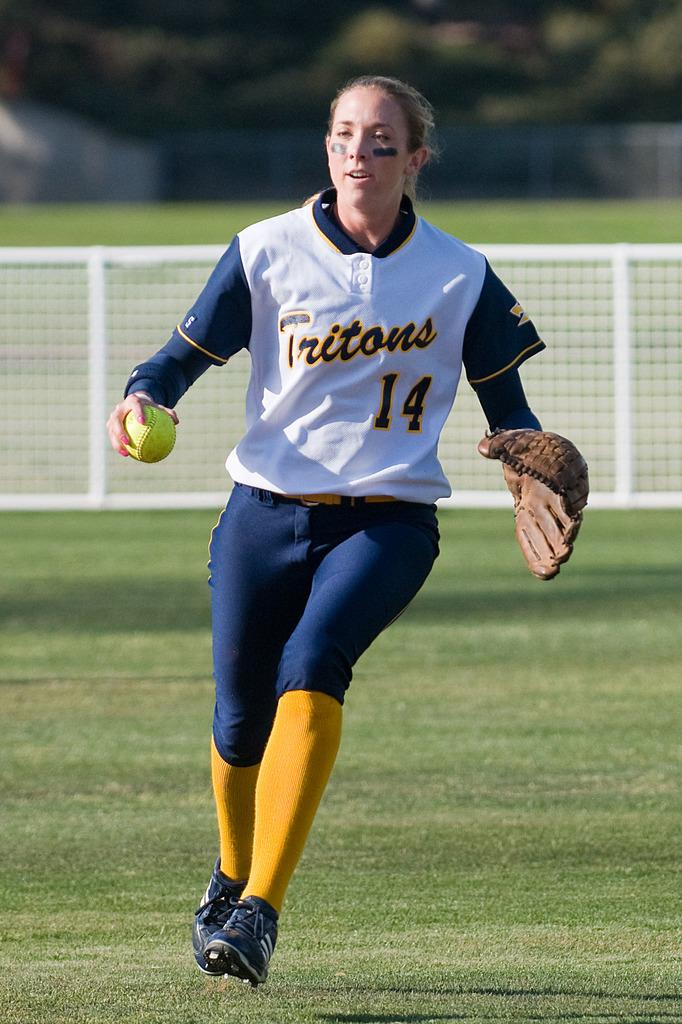<image>
Write a terse but informative summary of the picture. A baseball player is wearing a uniform with Tritons on the front. 